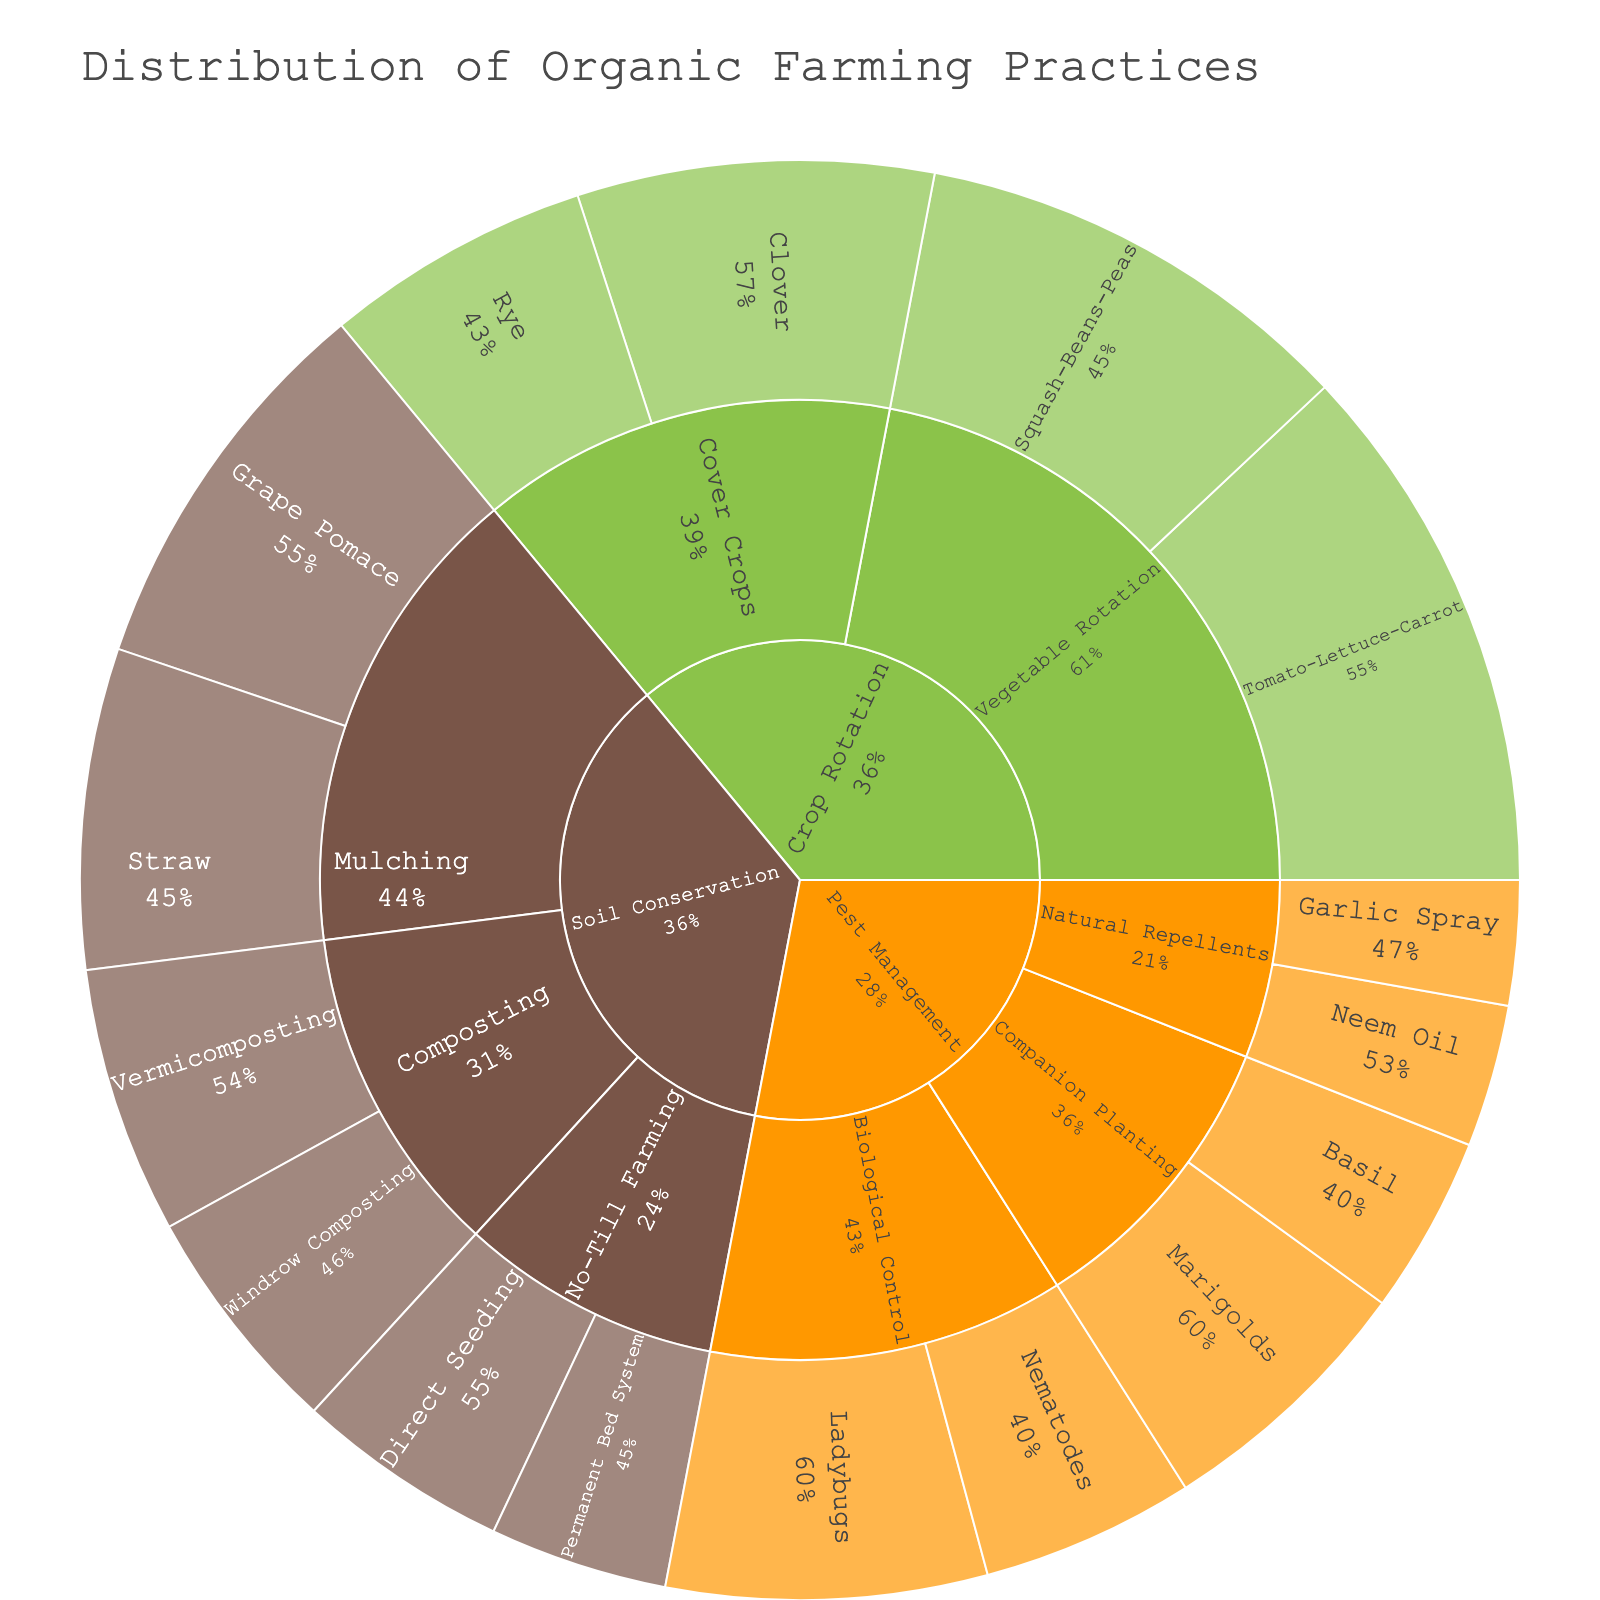what is the title of the plot? The title is displayed at the top of the plot and provides a summary of what the plot represents. In this case, it is clearly written as "Distribution of Organic Farming Practices".
Answer: Distribution of Organic Farming Practices Which soil conservation practice is associated with the highest value? The soil conservation category contains multiple practices. By examining the size of the sections within the soil conservation part of the sunburst plot, we can see that "Mulching with Grape Pomace" has the largest section.
Answer: Mulching with Grape Pomace How does the value of "Tomato-Lettuce-Carrot" crop rotation compare to "Squash-Beans-Peas" crop rotation? First, identify the sections for "Tomato-Lettuce-Carrot" and "Squash-Beans-Peas" under Crop Rotation -> Vegetable Rotation. "Tomato-Lettuce-Carrot" has a value of 30, and "Squash-Beans-Peas" has a value of 25. Comparing them, 30 is larger than 25.
Answer: Greater Which category represents the largest overall value? Look at the highest-level segments of the sunburst plot (Crop Rotation, Pest Management, Soil Conservation). Each segment's cumulative value can be inferred from the size. Crop Rotation has the largest cumulative size, indicating it represents the largest overall value.
Answer: Crop Rotation What percentage of the crop rotation is dedicated to cover crops? Crop Rotation is comprised of Vegetable Rotation and Cover Crops. Cover crops have individual segments for Clover and Rye. Summing their values (20 + 15 = 35) and considering the total Crop Rotation value (30+25+20+15), where the sum is 90, the percentage is (35/90) * 100%.
Answer: 38.9% What is the combined value of all pest management practices? Pest Management includes multiple subcategories: Biological Control, Companion Planting, and Natural Repellents. Summing all values: Ladybugs (18) + Nematodes (12) + Marigolds (15) + Basil (10) + Neem Oil (8) + Garlic Spray (7). The total is 18 + 12 + 15 + 10 + 8 + 7 = 70.
Answer: 70 Which category has the smallest value for its subcategory? Examine each category and its subcategories. The smallest value within a subcategory is in Pest Management -> Natural Repellents (Neem Oil: 8, Garlic Spray: 7) totaling 15. Comparing these to other lowest subcategory totals: Vegetable Rotation (55), Cover Crops (35), Biological Control (30), Companion Planting (25), Mulching (40), Composting (28), No-Till Farming (22). Natural Repellents have the smallest total.
Answer: Pest Management -> Natural Repellents How does "Composting" in soil conservation compare in value to "Vegetable Rotation" in crop rotation? Check the subcategories under Soil Conservation and Crop Rotation. "Composting" sums the values of Vermicomposting (15) and Windrow Composting (13), giving it a total of 28. "Vegetable Rotation" sums the values of Tomato-Lettuce-Carrot and Squash-Beans-Peas for a total of 55. Comparing 28 with 55, "Vegetable Rotation" has a higher value.
Answer: Less What is the value of the "Direct Seeding" practice in soil conservation? Locate "Direct Seeding" within the Soil Conservation category under the subcategory of No-Till Farming. The value associated with "Direct Seeding" shown in the plot is 12.
Answer: 12 